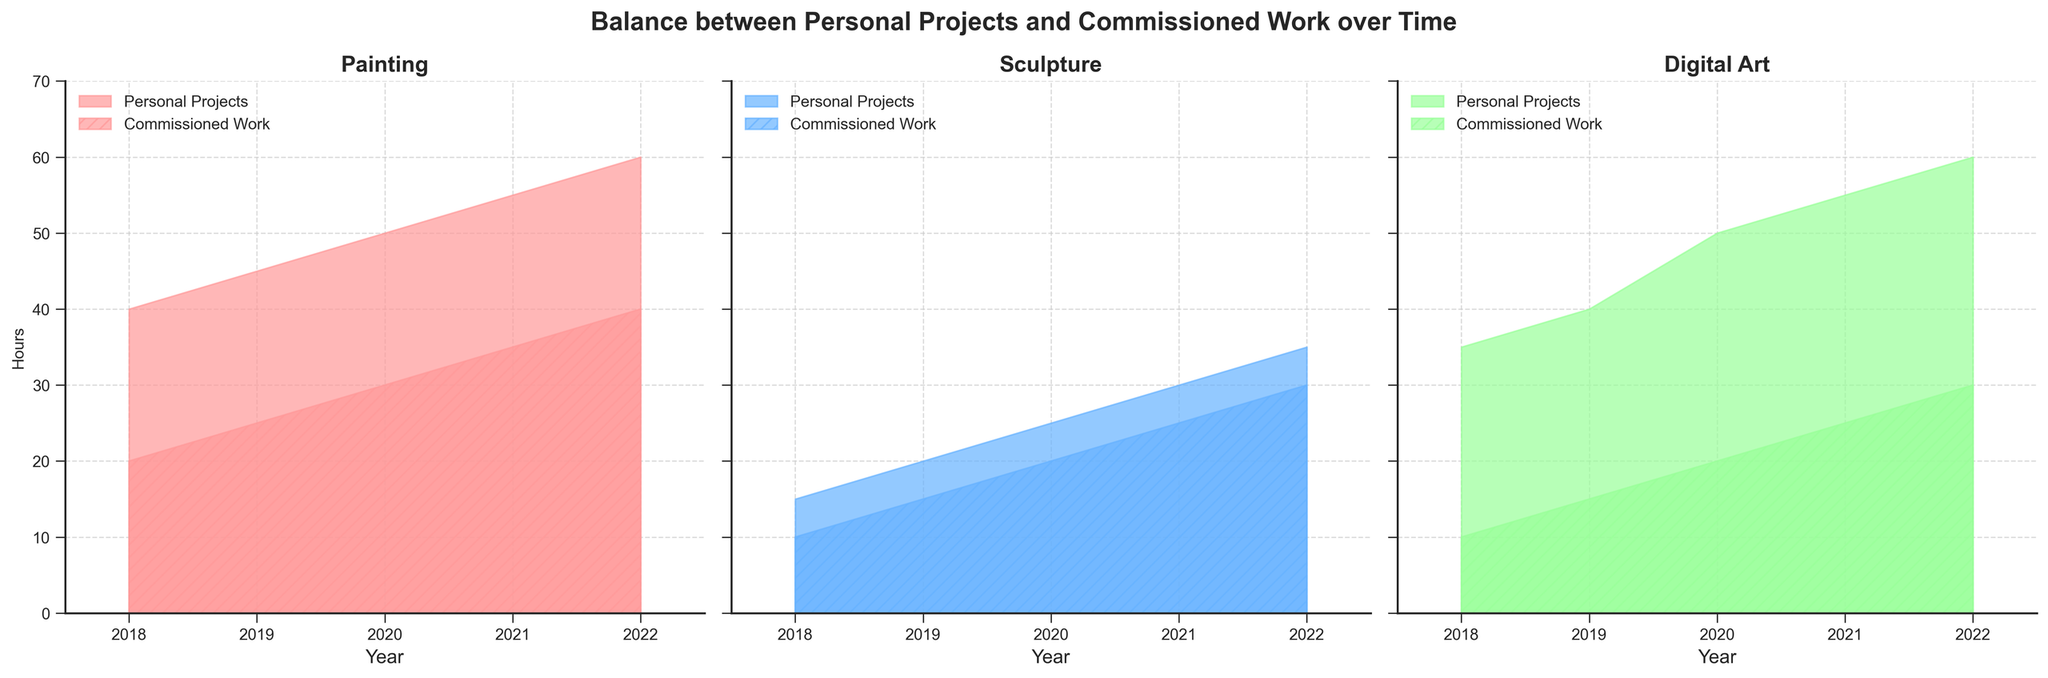What is the title of the figure? The title can be found at the top of the figure in bold text.
Answer: Balance between Personal Projects and Commissioned Work over Time How does the number of hours spent on personal projects in painting change from 2018 to 2022? By examining the area covered under the 'Personal Projects' section for painting from 2018 to 2022, it starts at 40 in 2018 and increases steadily to 60 in 2022.
Answer: Increases Which art form shows the highest increase in commissioned work hours from 2018 to 2022? Compare the end values of the 'Commissioned Work' sections from all art forms. The 'Commissioned Work' in painting increases from 30 in 2018 to 50 in 2022, sculpture goes from 25 to 45, and digital art goes from 20 to 40.
Answer: Painting Between sculpture and digital art, which had more hours dedicated to personal projects in 2019? Look at the 'Personal Projects' areas for sculpture and digital art in 2019. Sculpture had 20 hours, whereas digital art had 40 hours.
Answer: Digital Art In which years did personal projects for digital art see a significant increase? Observe the 'Personal Projects' area for digital art and note significant increases year over year. There is an increase from 35 (2018) to 40 (2019), and from 50 (2020) to 55 (2021) and to 60 (2022).
Answer: 2019, 2021, 2022 What is the difference in commissioned work hours for sculpture between 2018 and 2020? The 'Commissioned Work' area for sculpture shows 25 hours in 2018 and 35 hours in 2020. The difference is calculated as 35 - 25.
Answer: 10 hours Compare the years 2018 and 2021; which art form had more personal project hours compared to commissioned work? For each art form in the years 2018 and 2021, compare the values of personal projects and commissioned work. 
2018: 
- Painting: 40 personal, 30 commissioned 
- Sculpture: 15 personal, 25 commissioned
- Digital Art: 35 personal, 20 commissioned 
2021: 
- Painting: 55 personal, 45 commissioned 
- Sculpture: 30 personal, 40 commissioned
- Digital Art: 55 personal, 35 commissioned 
Painting and Digital Art have more personal hours than commissioned in 2021.
Answer: Painting, Digital Art In terms of commissioned work, which year saw the most balanced distribution across all art forms? Examine the 'Commissioned Work' areas for all art forms across years to see where the distribution appears equally balanced. In 2021, painting has 45, sculpture has 40, and digital art has 35, which is relatively balanced.
Answer: 2021 What trend is observable in personal projects for sculpture from 2018 to 2022? By viewing the 'Personal Projects' area for sculpture over the years, it increases from 15 in 2018 to 35 in 2022.
Answer: Increasing 